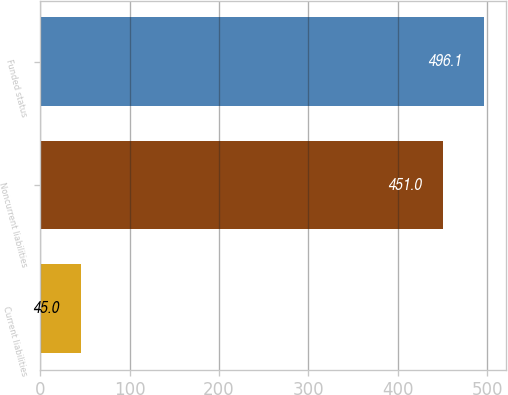Convert chart. <chart><loc_0><loc_0><loc_500><loc_500><bar_chart><fcel>Current liabilities<fcel>Noncurrent liabilities<fcel>Funded status<nl><fcel>45<fcel>451<fcel>496.1<nl></chart> 